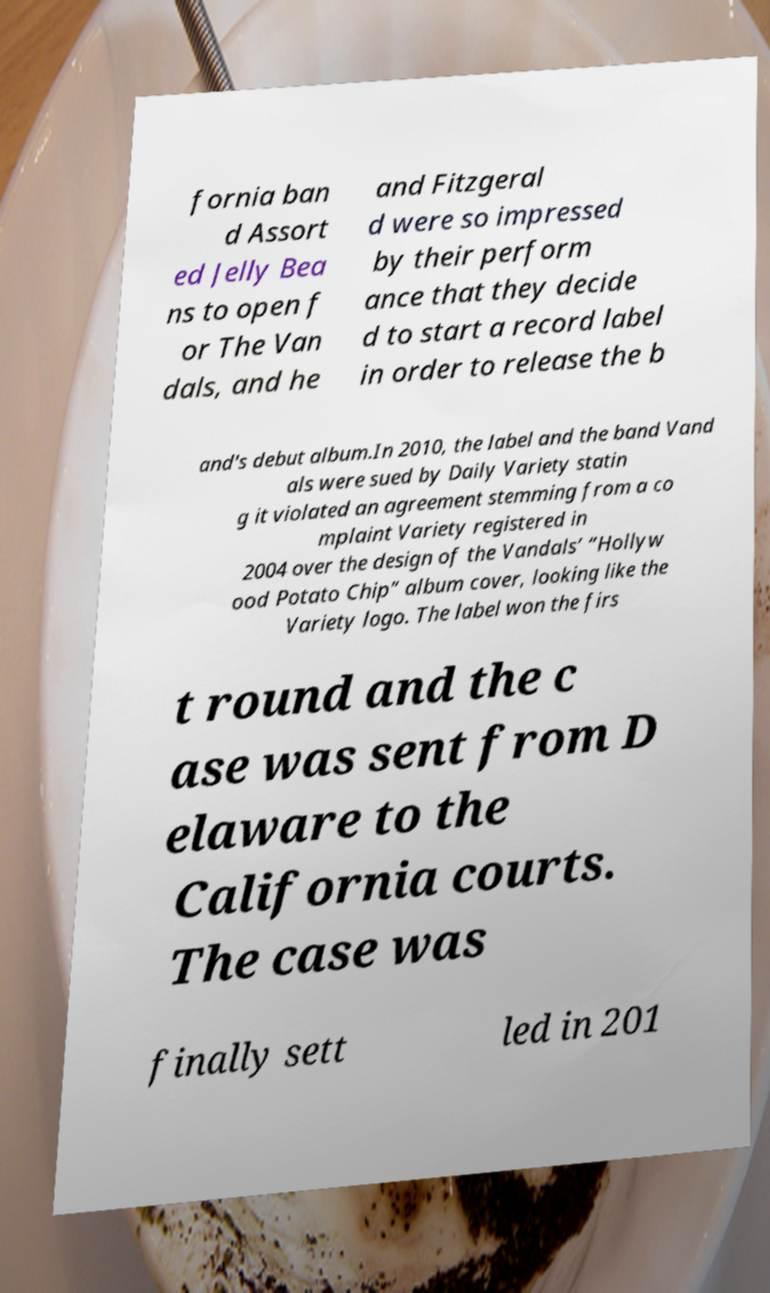Please identify and transcribe the text found in this image. fornia ban d Assort ed Jelly Bea ns to open f or The Van dals, and he and Fitzgeral d were so impressed by their perform ance that they decide d to start a record label in order to release the b and's debut album.In 2010, the label and the band Vand als were sued by Daily Variety statin g it violated an agreement stemming from a co mplaint Variety registered in 2004 over the design of the Vandals’ “Hollyw ood Potato Chip” album cover, looking like the Variety logo. The label won the firs t round and the c ase was sent from D elaware to the California courts. The case was finally sett led in 201 